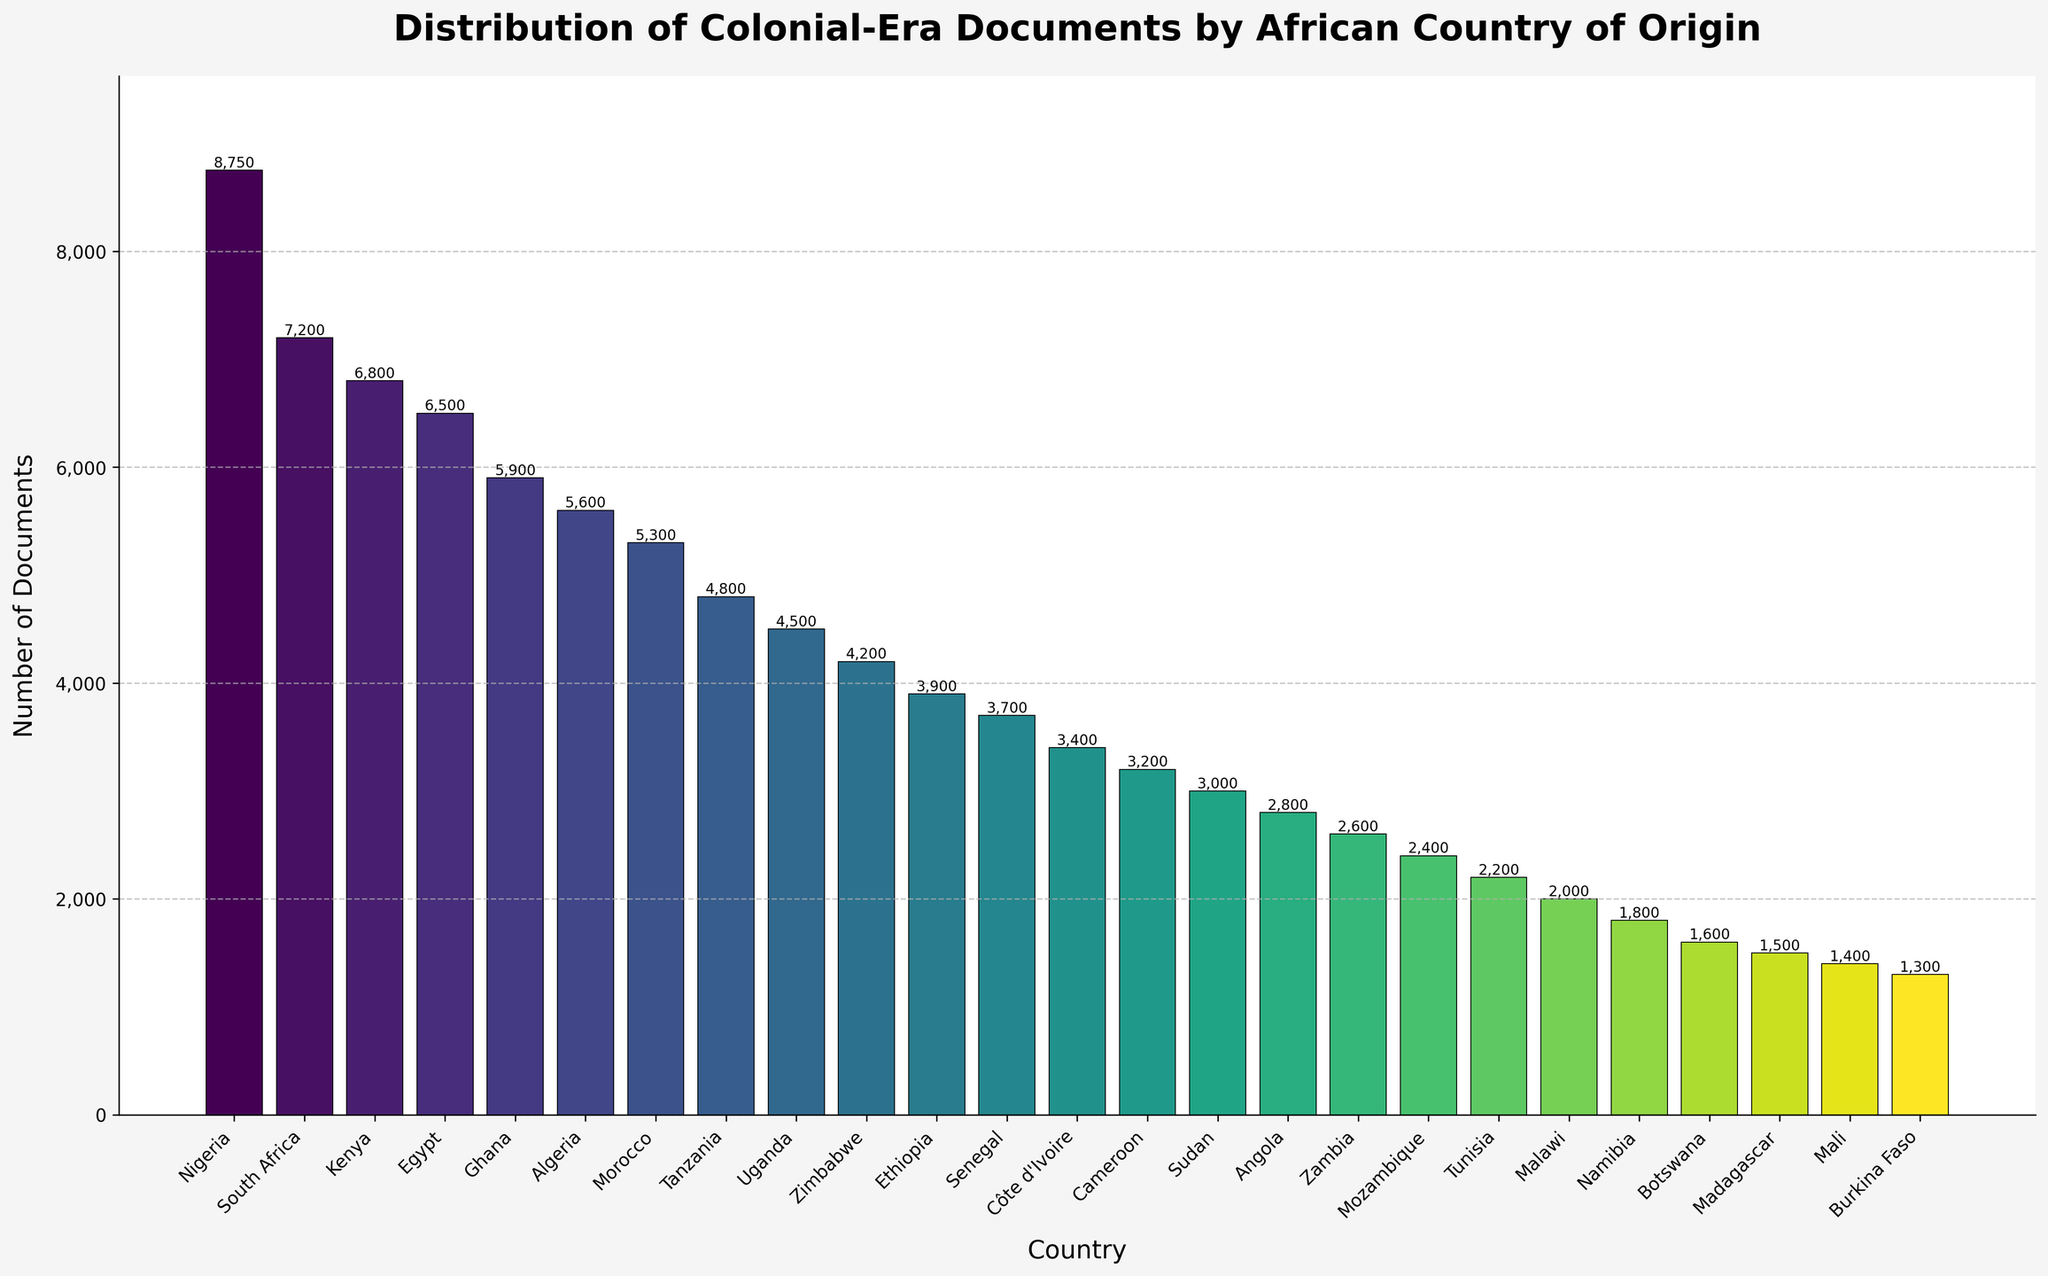What is the total number of colonial-era documents for Nigeria and Ghana combined? First, find the number of documents for Nigeria (8,750) and Ghana (5,900). Then, add them together: 8,750 + 5,900 = 14,650
Answer: 14,650 Which country has the highest number of colonial-era documents? Look for the tallest bar in the bar chart. The tallest bar represents Nigeria with 8,750 documents
Answer: Nigeria How does the number of colonial-era documents in Zimbabwe compare to that in South Africa? Find the values for Zimbabwe (4,200) and South Africa (7,200). Since 4,200 is less than 7,200, Zimbabwe has fewer documents than South Africa
Answer: Zimbabwe has fewer than South Africa What is the average number of colonial-era documents for the top three countries? Identify the top three countries (Nigeria: 8,750, South Africa: 7,200, Kenya: 6,800). Add their document counts: 8,750 + 7,200 + 6,800 = 22,750. Then, divide by 3: 22,750 ÷ 3 ≈ 7,583
Answer: 7,583 Which country has more colonial-era documents, Cameroon or Sudan? Check the values for Cameroon (3,200) and Sudan (3,000). Since 3,200 is greater than 3,000, Cameroon has more documents than Sudan
Answer: Cameroon How many more colonial-era documents does Kenya have compared to Ethiopia? Subtract the number of documents for Ethiopia (3,900) from that for Kenya (6,800): 6,800 - 3,900 = 2,900
Answer: 2,900 What are the countries that have fewer than 3,000 colonial-era documents? Identify the countries with bars shorter than 3,000 on the y-axis: Tunisia (2,200), Malawi (2,000), Namibia (1,800), Botswana (1,600), Madagascar (1,500), Mali (1,400), Burkina Faso (1,300)
Answer: Tunisia, Malawi, Namibia, Botswana, Madagascar, Mali, Burkina Faso What is the combined number of colonial-era documents from Algeria, Morocco, and Tunisia? Add the document counts for Algeria (5,600), Morocco (5,300), and Tunisia (2,200): 5,600 + 5,300 + 2,200 = 13,100
Answer: 13,100 Is Ghana among the top 5 countries in terms of the number of colonial-era documents? The top 5 countries are identified by the five tallest bars, representing Nigeria, South Africa, Kenya, Egypt, and Ghana
Answer: Yes What is the difference in the number of colonial-era documents between Egypt and Tanzania? Subtract the number of documents for Tanzania (4,800) from that for Egypt (6,500): 6,500 - 4,800 = 1,700
Answer: 1,700 